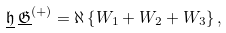<formula> <loc_0><loc_0><loc_500><loc_500>\underline { \mathfrak { h } } \, \underline { \mathfrak { G } } ^ { ( + ) } = \aleph \left \{ { W } _ { 1 } + { W } _ { 2 } + { W } _ { 3 } \right \} ,</formula> 